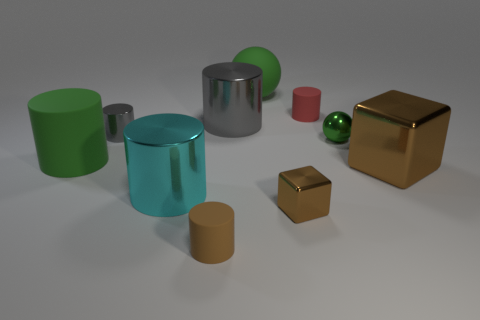What number of large green things are made of the same material as the green cylinder?
Your answer should be very brief. 1. What color is the big ball that is the same material as the small red cylinder?
Your response must be concise. Green. There is a tiny shiny cylinder that is on the right side of the big green rubber cylinder; does it have the same color as the large metallic block?
Keep it short and to the point. No. There is a green thing that is on the right side of the green rubber sphere; what is it made of?
Your response must be concise. Metal. Are there an equal number of tiny gray cylinders that are behind the big rubber cylinder and large cyan metal cylinders?
Ensure brevity in your answer.  Yes. How many large blocks are the same color as the tiny block?
Your answer should be compact. 1. The small shiny object that is the same shape as the large gray thing is what color?
Make the answer very short. Gray. Do the brown rubber cylinder and the green cylinder have the same size?
Ensure brevity in your answer.  No. Are there an equal number of metal cubes that are behind the big gray cylinder and big metallic cubes that are on the right side of the tiny brown matte object?
Your response must be concise. No. Are there any rubber objects?
Provide a succinct answer. Yes. 